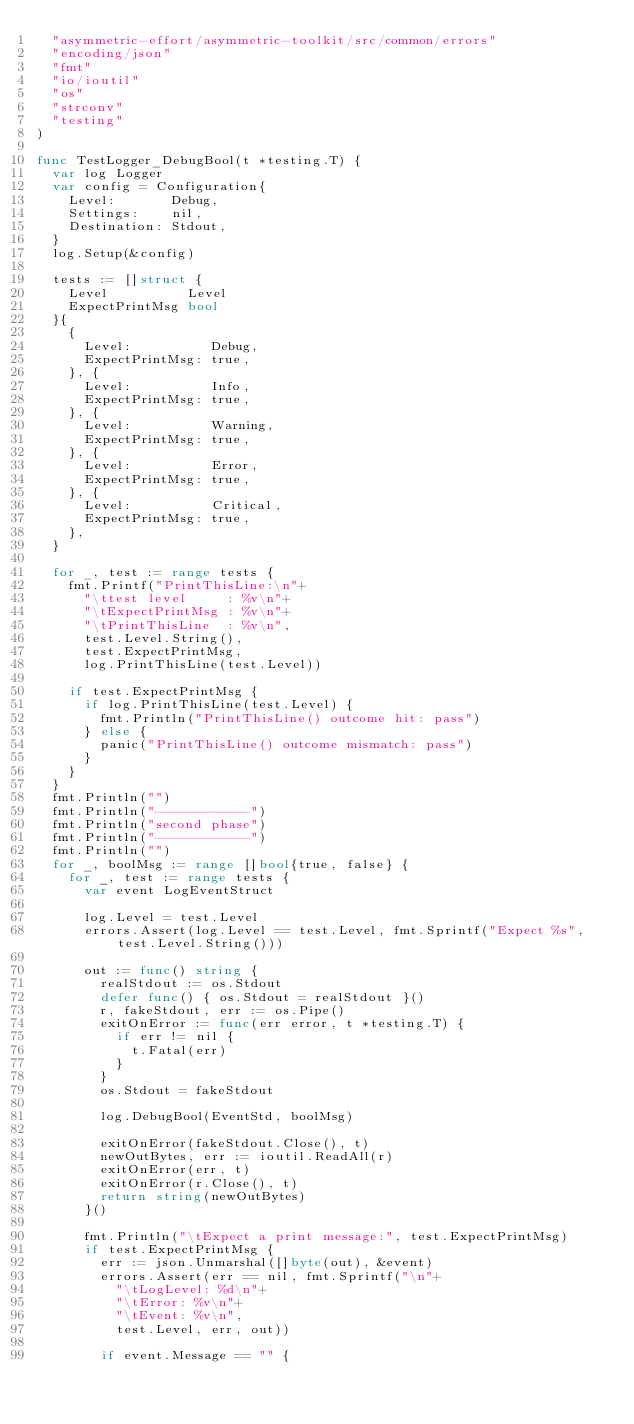<code> <loc_0><loc_0><loc_500><loc_500><_Go_>	"asymmetric-effort/asymmetric-toolkit/src/common/errors"
	"encoding/json"
	"fmt"
	"io/ioutil"
	"os"
	"strconv"
	"testing"
)

func TestLogger_DebugBool(t *testing.T) {
	var log Logger
	var config = Configuration{
		Level:       Debug,
		Settings:    nil,
		Destination: Stdout,
	}
	log.Setup(&config)

	tests := []struct {
		Level          Level
		ExpectPrintMsg bool
	}{
		{
			Level:          Debug,
			ExpectPrintMsg: true,
		}, {
			Level:          Info,
			ExpectPrintMsg: true,
		}, {
			Level:          Warning,
			ExpectPrintMsg: true,
		}, {
			Level:          Error,
			ExpectPrintMsg: true,
		}, {
			Level:          Critical,
			ExpectPrintMsg: true,
		},
	}

	for _, test := range tests {
		fmt.Printf("PrintThisLine:\n"+
			"\ttest level     : %v\n"+
			"\tExpectPrintMsg : %v\n"+
			"\tPrintThisLine  : %v\n",
			test.Level.String(),
			test.ExpectPrintMsg,
			log.PrintThisLine(test.Level))

		if test.ExpectPrintMsg {
			if log.PrintThisLine(test.Level) {
				fmt.Println("PrintThisLine() outcome hit: pass")
			} else {
				panic("PrintThisLine() outcome mismatch: pass")
			}
		}
	}
	fmt.Println("")
	fmt.Println("------------")
	fmt.Println("second phase")
	fmt.Println("------------")
	fmt.Println("")
	for _, boolMsg := range []bool{true, false} {
		for _, test := range tests {
			var event LogEventStruct

			log.Level = test.Level
			errors.Assert(log.Level == test.Level, fmt.Sprintf("Expect %s", test.Level.String()))

			out := func() string {
				realStdout := os.Stdout
				defer func() { os.Stdout = realStdout }()
				r, fakeStdout, err := os.Pipe()
				exitOnError := func(err error, t *testing.T) {
					if err != nil {
						t.Fatal(err)
					}
				}
				os.Stdout = fakeStdout

				log.DebugBool(EventStd, boolMsg)

				exitOnError(fakeStdout.Close(), t)
				newOutBytes, err := ioutil.ReadAll(r)
				exitOnError(err, t)
				exitOnError(r.Close(), t)
				return string(newOutBytes)
			}()

			fmt.Println("\tExpect a print message:", test.ExpectPrintMsg)
			if test.ExpectPrintMsg {
				err := json.Unmarshal([]byte(out), &event)
				errors.Assert(err == nil, fmt.Sprintf("\n"+
					"\tLogLevel: %d\n"+
					"\tError: %v\n"+
					"\tEvent: %v\n",
					test.Level, err, out))

				if event.Message == "" {</code> 